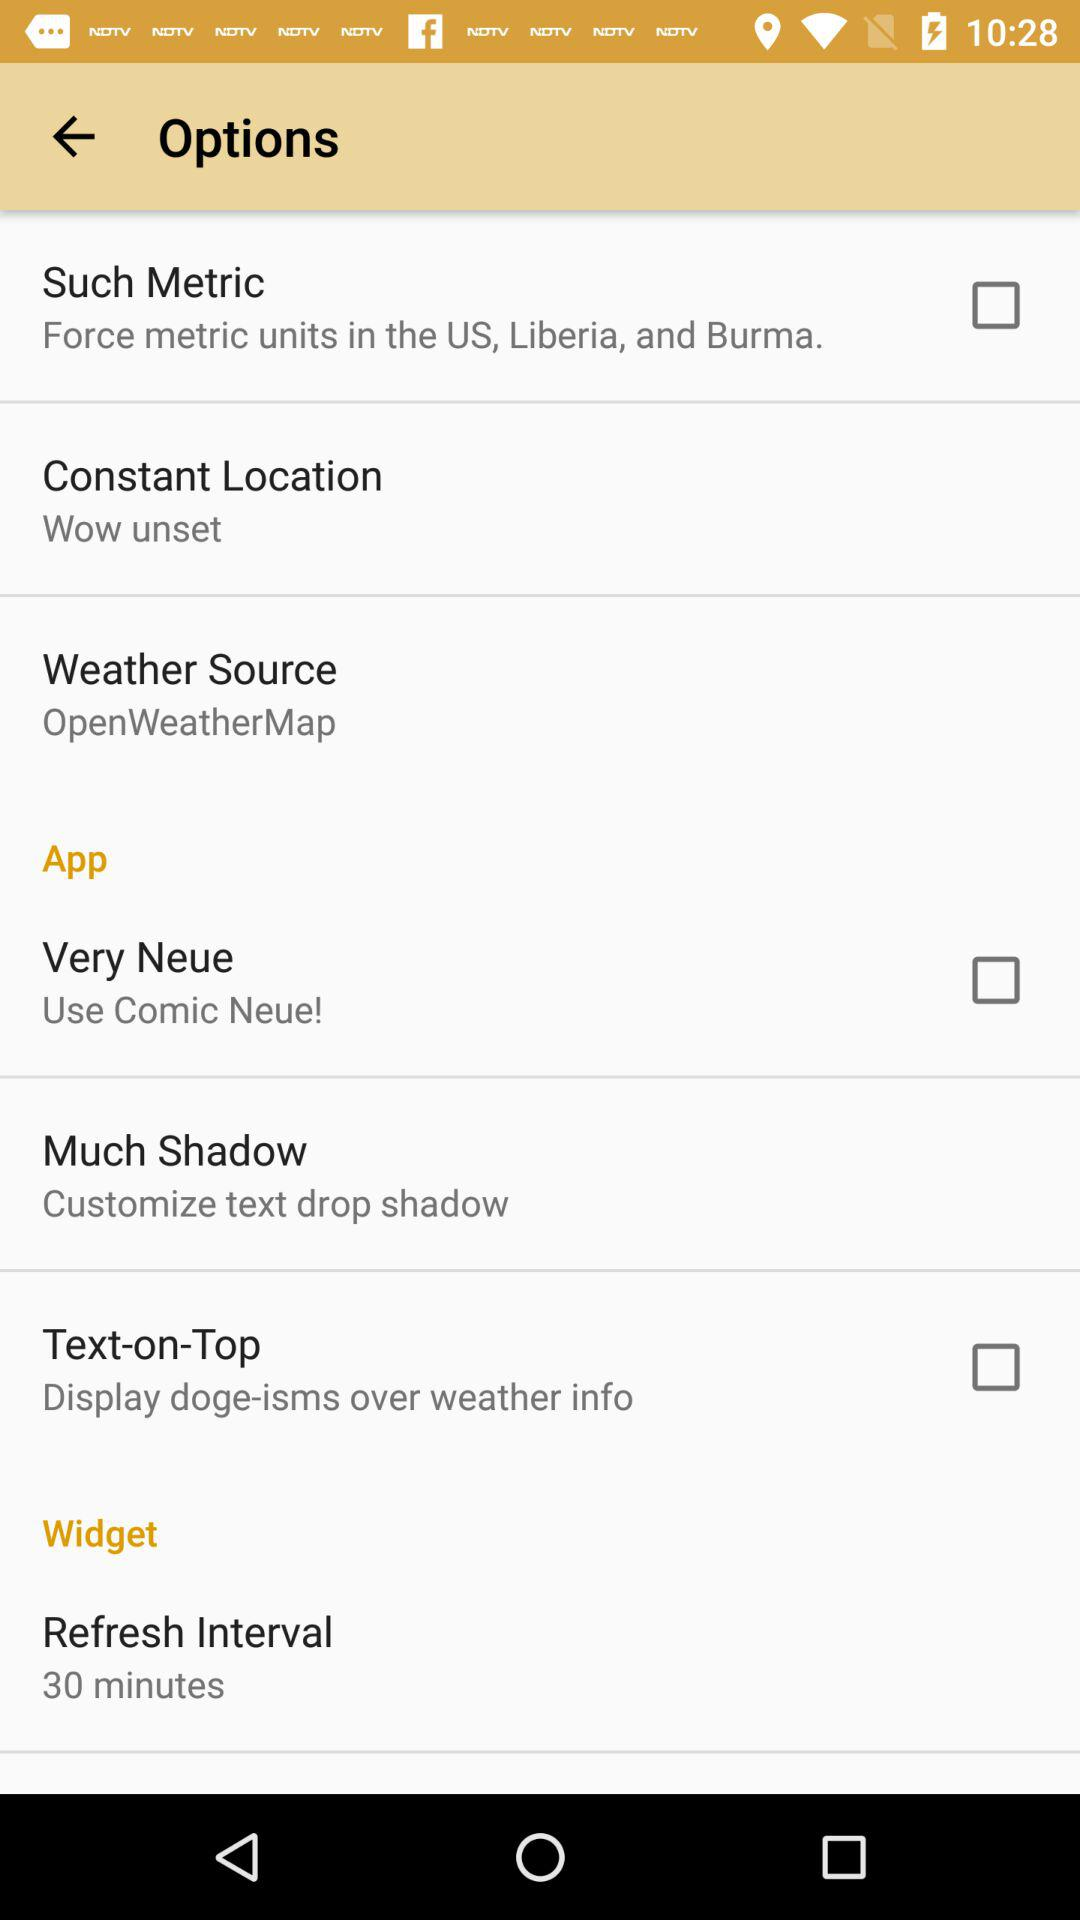What is the time duration of the refresh interval? The time duration of the refresh interval is 30 minutes. 